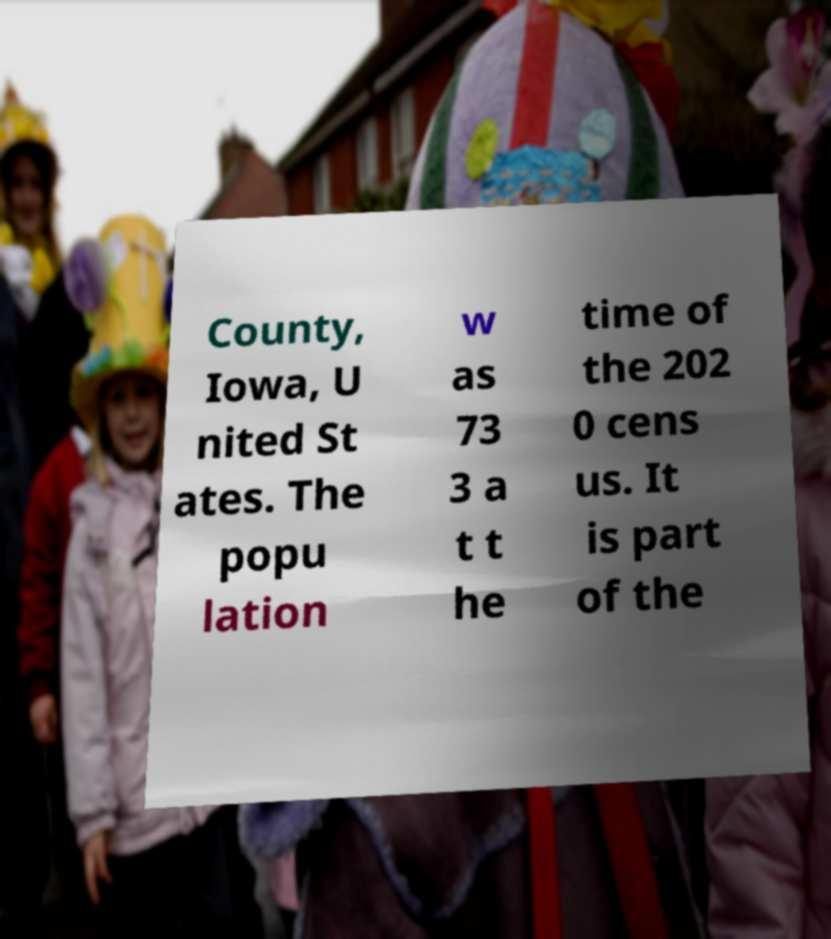What messages or text are displayed in this image? I need them in a readable, typed format. County, Iowa, U nited St ates. The popu lation w as 73 3 a t t he time of the 202 0 cens us. It is part of the 